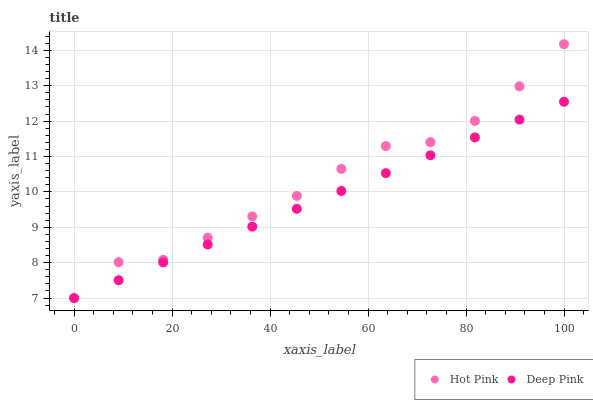Does Deep Pink have the minimum area under the curve?
Answer yes or no. Yes. Does Hot Pink have the maximum area under the curve?
Answer yes or no. Yes. Does Deep Pink have the maximum area under the curve?
Answer yes or no. No. Is Deep Pink the smoothest?
Answer yes or no. Yes. Is Hot Pink the roughest?
Answer yes or no. Yes. Is Deep Pink the roughest?
Answer yes or no. No. Does Hot Pink have the lowest value?
Answer yes or no. Yes. Does Hot Pink have the highest value?
Answer yes or no. Yes. Does Deep Pink have the highest value?
Answer yes or no. No. Does Hot Pink intersect Deep Pink?
Answer yes or no. Yes. Is Hot Pink less than Deep Pink?
Answer yes or no. No. Is Hot Pink greater than Deep Pink?
Answer yes or no. No. 